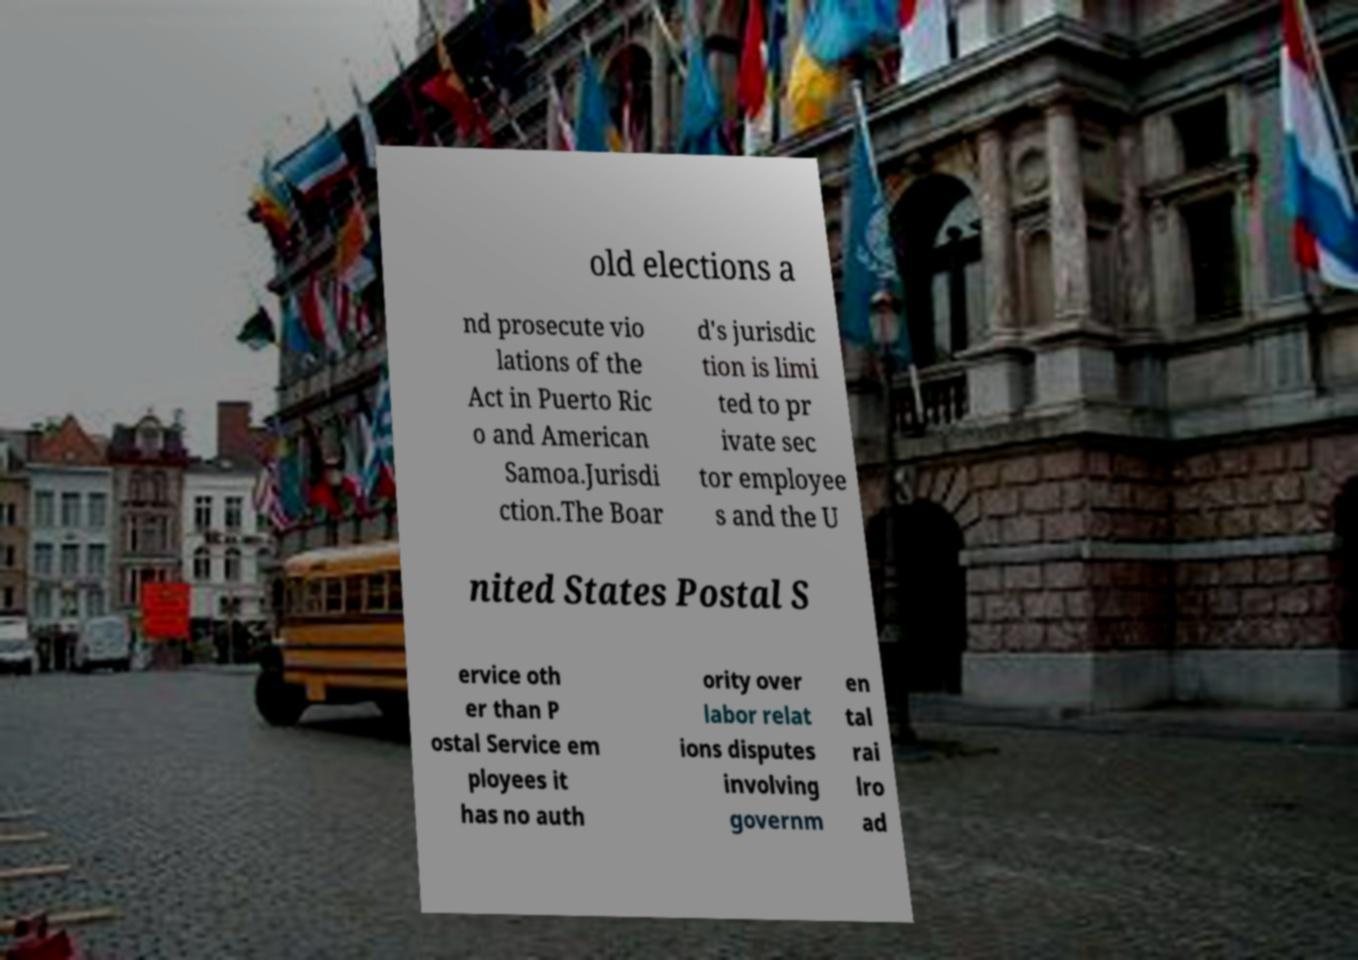What messages or text are displayed in this image? I need them in a readable, typed format. old elections a nd prosecute vio lations of the Act in Puerto Ric o and American Samoa.Jurisdi ction.The Boar d's jurisdic tion is limi ted to pr ivate sec tor employee s and the U nited States Postal S ervice oth er than P ostal Service em ployees it has no auth ority over labor relat ions disputes involving governm en tal rai lro ad 